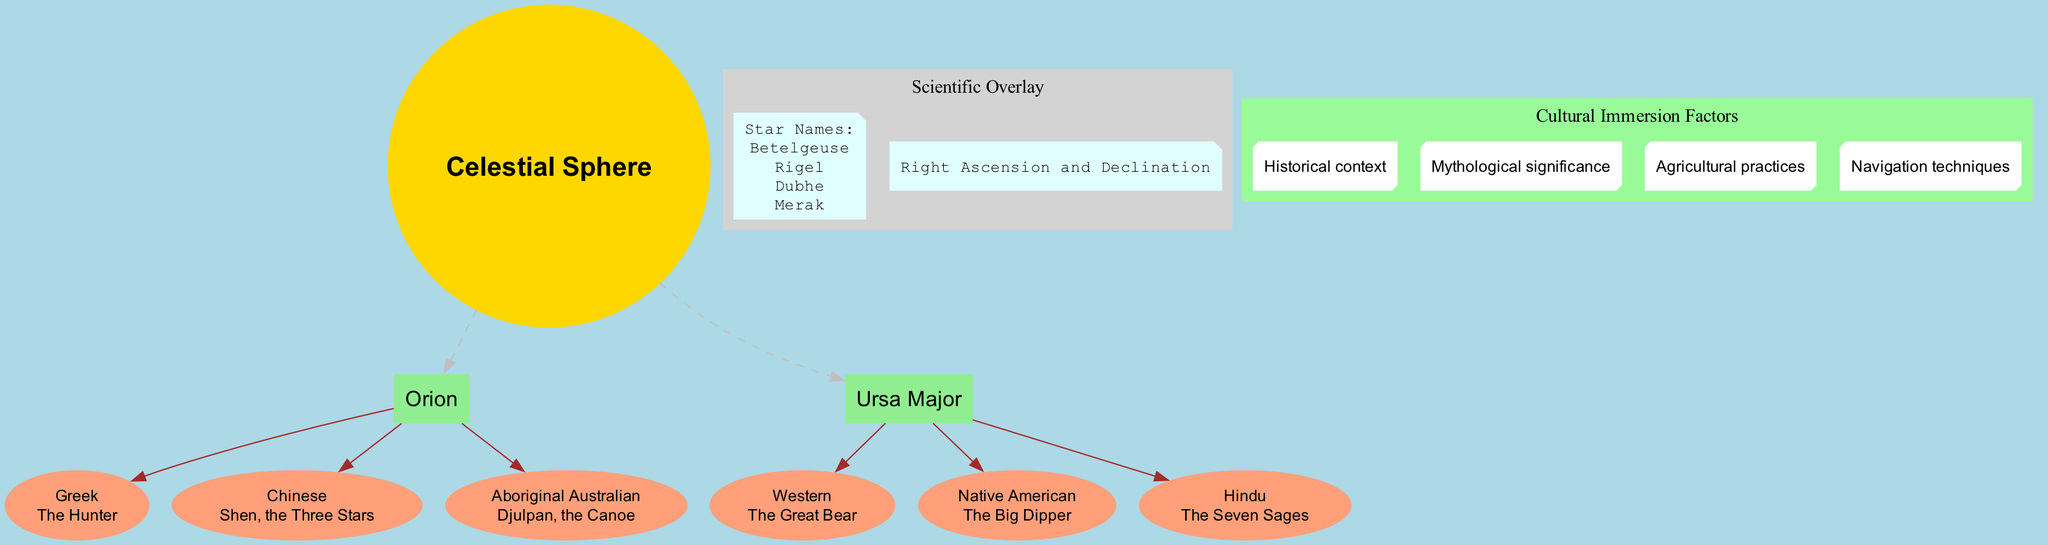What culture interprets Orion as "The Hunter"? The diagram lists cultural interpretations of Orion; specifically, the Greek culture interprets it as "The Hunter."
Answer: Greek How many constellations are represented in the diagram? The diagram shows two constellations: Orion and Ursa Major. Counting these nodes gives a total of two.
Answer: 2 What is the interpretation of Ursa Major in Native American culture? Referring to the section on Ursa Major, it states that Native American interpretation is "The Big Dipper."
Answer: The Big Dipper Which star is listed first in the scientific overlay section? The scientific overlay node includes a list of star names, with "Betelgeuse" appearing first in that list.
Answer: Betelgeuse What is the relationship between "Ursa Major" and "The Seven Sages"? In the diagram, "Ursa Major" is connected to its cultural interpretation "The Seven Sages" through an edge, indicating that this interpretation belongs to the constellation Ursa Major in Hindu culture.
Answer: Connected How many cultural immersion factors are identified in the diagram? The cultural immersion factors node lists four distinct factors regarding cultural interpretations of constellations. Counting these factors provides the answer.
Answer: 4 Which constellation has the overlay of "Shen, the Three Stars"? The diagram shows that the constellation Orion has the cultural interpretation "Shen, the Three Stars" attributed to Chinese culture.
Answer: Orion What do the two stars "Dubhe" and "Merak" have in common? Both "Dubhe" and "Merak" are listed under the scientific overlay section as names of stars, indicating their association with constellations.
Answer: Star names What cultural interpretation is associated with Aboriginal Australian for Orion? The diagram specifies that Aboriginal Australian culture interprets Orion as "Djulpan, the Canoe."
Answer: Djulpan, the Canoe 